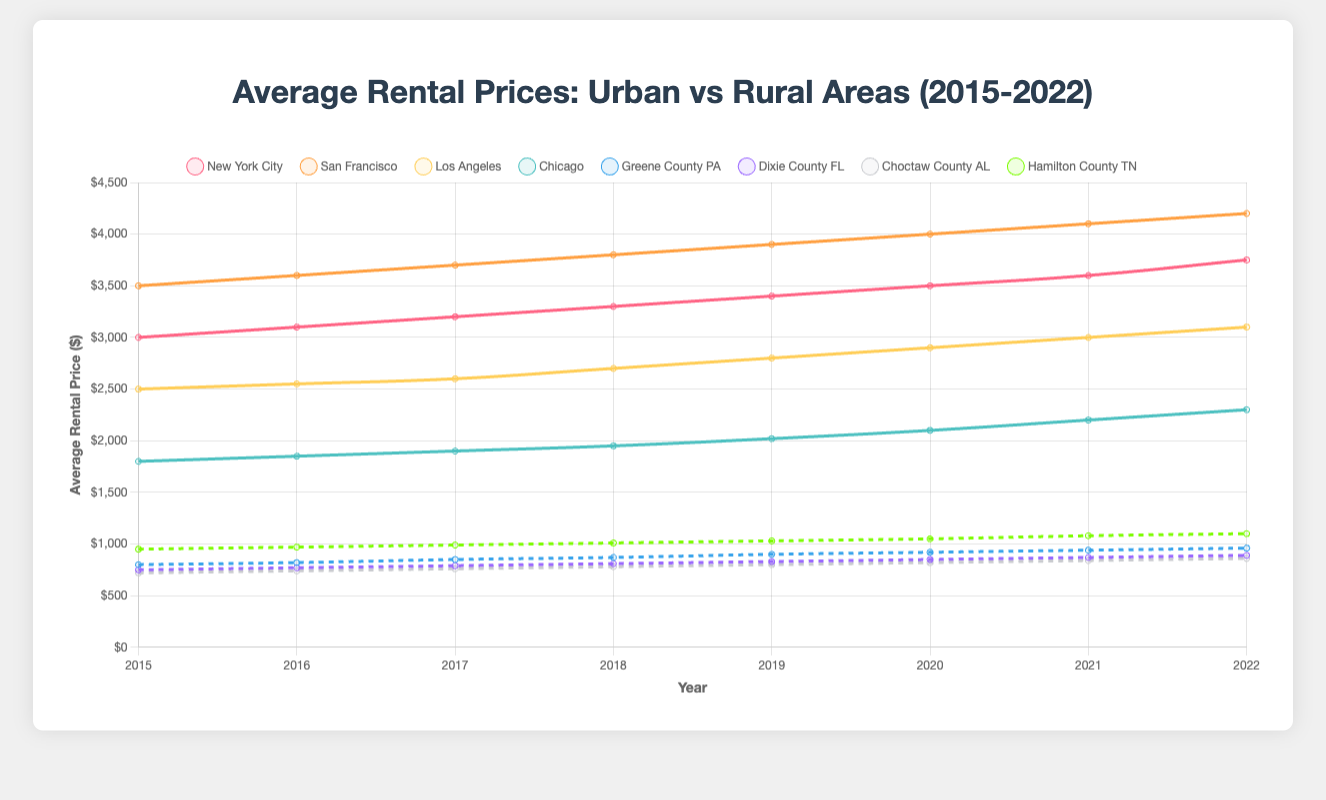What's the average rental price in New York City and Greene County PA in 2020? To find the average rental price, add the rental prices in 2020 for New York City ($3500) and Greene County, PA ($920) and then divide by the number of data points (2). Calculation: (3500 + 920) / 2 = 4420 / 2 = 2210
Answer: 2210 How does the rental price trend of San Francisco compare to Dixie County, FL from 2015 to 2022? Observe the slopes of the lines for San Francisco and Dixie County, FL. San Francisco shows a consistent upward trend with higher rental prices over time, starting from $3500 in 2015 to $4200 in 2022. Dixie County, FL also shows an upward trend but with much lower rental prices, starting from $750 in 2015 and reaching $890 in 2022. Thus, both areas have increasing trends, but San Francisco has a much higher increase in prices.
Answer: Both have increasing trends, but San Francisco has a higher increase Which rural area had the highest average rental price in 2019? Compare the rental prices in 2019 for all rural areas: Greene County, PA ($900), Dixie County, FL ($830), Choctaw County, AL ($800), and Hamilton County, TN ($1030). The highest value is for Hamilton County, TN.
Answer: Hamilton County, TN Between Los Angeles and Chicago, which city had a larger increase in rental prices from 2015 to 2022? Calculate the increase in rental prices for both cities from 2015 to 2022. For Los Angeles: $3100 - $2500 = $600. For Chicago: $2300 - $1800 = $500. Los Angeles had a larger increase ($600).
Answer: Los Angeles What is the difference in rental prices between the highest and lowest urban areas in 2022? Identify the highest and lowest rental prices in 2022 among urban areas. The highest is San Francisco ($4200) and the lowest is Chicago ($2300). Calculate the difference: $4200 - $2300 = $1900.
Answer: 1900 Which area saw the most consistent increase in rental prices over the period, and how can you tell? By examining the lines for each area, Greene County, PA, shows a relatively consistent increase each year, with small and steady increments from $800 in 2015 to $960 in 2022. The line is uniform without drastic changes.
Answer: Greene County, PA By how much did the rental price in Hamilton County, TN increase from 2018 to 2020, and what is the percentage increase? Calculate the increase: $1050 (2020) - $1010 (2018) = $40. Then, calculate the percentage increase: ($40 / $1010) * 100 ≈ 3.96%.
Answer: $40, ~3.96% Which urban area had the smallest rental price in 2016 and what was the value? Compare the 2016 rental prices in urban areas: New York City ($3100), San Francisco ($3600), Los Angeles ($2550), and Chicago ($1850). Chicago had the smallest rental price ($1850).
Answer: Chicago, $1850 